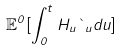Convert formula to latex. <formula><loc_0><loc_0><loc_500><loc_500>\mathbb { E } ^ { 0 } [ \int _ { 0 } ^ { t } H _ { u } \theta _ { u } d u ]</formula> 